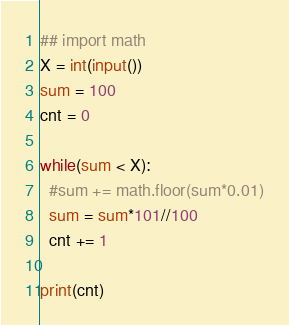Convert code to text. <code><loc_0><loc_0><loc_500><loc_500><_Python_>## import math
X = int(input())
sum = 100
cnt = 0

while(sum < X):
  #sum += math.floor(sum*0.01)
  sum = sum*101//100
  cnt += 1

print(cnt)</code> 